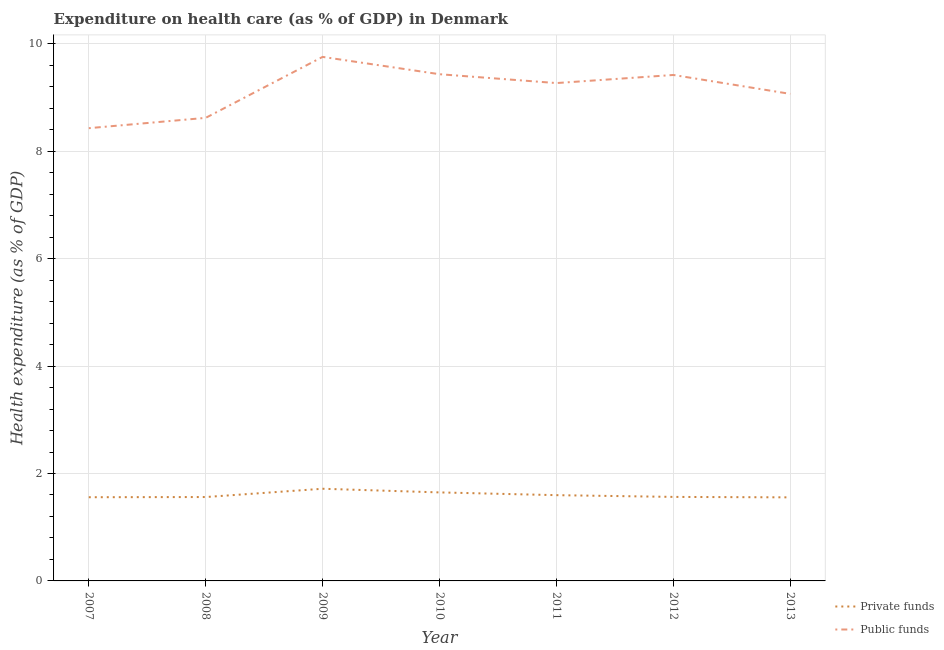How many different coloured lines are there?
Keep it short and to the point. 2. Does the line corresponding to amount of public funds spent in healthcare intersect with the line corresponding to amount of private funds spent in healthcare?
Your response must be concise. No. Is the number of lines equal to the number of legend labels?
Your answer should be very brief. Yes. What is the amount of public funds spent in healthcare in 2013?
Provide a short and direct response. 9.07. Across all years, what is the maximum amount of public funds spent in healthcare?
Provide a succinct answer. 9.76. Across all years, what is the minimum amount of public funds spent in healthcare?
Your answer should be very brief. 8.43. In which year was the amount of private funds spent in healthcare maximum?
Offer a terse response. 2009. What is the total amount of public funds spent in healthcare in the graph?
Your response must be concise. 64. What is the difference between the amount of public funds spent in healthcare in 2007 and that in 2012?
Your response must be concise. -0.99. What is the difference between the amount of public funds spent in healthcare in 2013 and the amount of private funds spent in healthcare in 2012?
Your answer should be very brief. 7.5. What is the average amount of private funds spent in healthcare per year?
Keep it short and to the point. 1.6. In the year 2013, what is the difference between the amount of public funds spent in healthcare and amount of private funds spent in healthcare?
Your answer should be very brief. 7.51. What is the ratio of the amount of private funds spent in healthcare in 2008 to that in 2013?
Offer a terse response. 1. Is the difference between the amount of private funds spent in healthcare in 2012 and 2013 greater than the difference between the amount of public funds spent in healthcare in 2012 and 2013?
Keep it short and to the point. No. What is the difference between the highest and the second highest amount of private funds spent in healthcare?
Keep it short and to the point. 0.07. What is the difference between the highest and the lowest amount of private funds spent in healthcare?
Provide a short and direct response. 0.16. Is the sum of the amount of public funds spent in healthcare in 2009 and 2010 greater than the maximum amount of private funds spent in healthcare across all years?
Your answer should be compact. Yes. Is the amount of public funds spent in healthcare strictly greater than the amount of private funds spent in healthcare over the years?
Give a very brief answer. Yes. Is the amount of public funds spent in healthcare strictly less than the amount of private funds spent in healthcare over the years?
Provide a short and direct response. No. How many lines are there?
Offer a very short reply. 2. How many years are there in the graph?
Offer a very short reply. 7. What is the difference between two consecutive major ticks on the Y-axis?
Provide a short and direct response. 2. Are the values on the major ticks of Y-axis written in scientific E-notation?
Your answer should be very brief. No. Does the graph contain grids?
Offer a terse response. Yes. How many legend labels are there?
Give a very brief answer. 2. What is the title of the graph?
Provide a short and direct response. Expenditure on health care (as % of GDP) in Denmark. What is the label or title of the X-axis?
Provide a short and direct response. Year. What is the label or title of the Y-axis?
Provide a succinct answer. Health expenditure (as % of GDP). What is the Health expenditure (as % of GDP) in Private funds in 2007?
Make the answer very short. 1.56. What is the Health expenditure (as % of GDP) in Public funds in 2007?
Offer a very short reply. 8.43. What is the Health expenditure (as % of GDP) in Private funds in 2008?
Give a very brief answer. 1.56. What is the Health expenditure (as % of GDP) in Public funds in 2008?
Your response must be concise. 8.62. What is the Health expenditure (as % of GDP) in Private funds in 2009?
Provide a succinct answer. 1.72. What is the Health expenditure (as % of GDP) of Public funds in 2009?
Give a very brief answer. 9.76. What is the Health expenditure (as % of GDP) of Private funds in 2010?
Offer a terse response. 1.65. What is the Health expenditure (as % of GDP) of Public funds in 2010?
Provide a short and direct response. 9.43. What is the Health expenditure (as % of GDP) of Private funds in 2011?
Provide a short and direct response. 1.6. What is the Health expenditure (as % of GDP) of Public funds in 2011?
Ensure brevity in your answer.  9.27. What is the Health expenditure (as % of GDP) in Private funds in 2012?
Your answer should be compact. 1.56. What is the Health expenditure (as % of GDP) of Public funds in 2012?
Your response must be concise. 9.42. What is the Health expenditure (as % of GDP) in Private funds in 2013?
Your response must be concise. 1.56. What is the Health expenditure (as % of GDP) in Public funds in 2013?
Provide a succinct answer. 9.07. Across all years, what is the maximum Health expenditure (as % of GDP) in Private funds?
Make the answer very short. 1.72. Across all years, what is the maximum Health expenditure (as % of GDP) of Public funds?
Make the answer very short. 9.76. Across all years, what is the minimum Health expenditure (as % of GDP) in Private funds?
Your answer should be very brief. 1.56. Across all years, what is the minimum Health expenditure (as % of GDP) of Public funds?
Make the answer very short. 8.43. What is the total Health expenditure (as % of GDP) of Private funds in the graph?
Keep it short and to the point. 11.2. What is the total Health expenditure (as % of GDP) in Public funds in the graph?
Ensure brevity in your answer.  64. What is the difference between the Health expenditure (as % of GDP) in Private funds in 2007 and that in 2008?
Offer a terse response. -0. What is the difference between the Health expenditure (as % of GDP) in Public funds in 2007 and that in 2008?
Offer a terse response. -0.19. What is the difference between the Health expenditure (as % of GDP) in Private funds in 2007 and that in 2009?
Give a very brief answer. -0.16. What is the difference between the Health expenditure (as % of GDP) in Public funds in 2007 and that in 2009?
Your response must be concise. -1.33. What is the difference between the Health expenditure (as % of GDP) of Private funds in 2007 and that in 2010?
Provide a short and direct response. -0.09. What is the difference between the Health expenditure (as % of GDP) of Public funds in 2007 and that in 2010?
Provide a short and direct response. -1. What is the difference between the Health expenditure (as % of GDP) in Private funds in 2007 and that in 2011?
Provide a short and direct response. -0.04. What is the difference between the Health expenditure (as % of GDP) in Public funds in 2007 and that in 2011?
Make the answer very short. -0.84. What is the difference between the Health expenditure (as % of GDP) in Private funds in 2007 and that in 2012?
Provide a short and direct response. -0.01. What is the difference between the Health expenditure (as % of GDP) of Public funds in 2007 and that in 2012?
Your response must be concise. -0.99. What is the difference between the Health expenditure (as % of GDP) of Private funds in 2007 and that in 2013?
Your answer should be very brief. 0. What is the difference between the Health expenditure (as % of GDP) in Public funds in 2007 and that in 2013?
Your response must be concise. -0.64. What is the difference between the Health expenditure (as % of GDP) of Private funds in 2008 and that in 2009?
Ensure brevity in your answer.  -0.15. What is the difference between the Health expenditure (as % of GDP) of Public funds in 2008 and that in 2009?
Provide a succinct answer. -1.13. What is the difference between the Health expenditure (as % of GDP) in Private funds in 2008 and that in 2010?
Your answer should be compact. -0.09. What is the difference between the Health expenditure (as % of GDP) in Public funds in 2008 and that in 2010?
Your response must be concise. -0.81. What is the difference between the Health expenditure (as % of GDP) of Private funds in 2008 and that in 2011?
Your response must be concise. -0.03. What is the difference between the Health expenditure (as % of GDP) in Public funds in 2008 and that in 2011?
Your answer should be compact. -0.65. What is the difference between the Health expenditure (as % of GDP) of Private funds in 2008 and that in 2012?
Offer a terse response. -0. What is the difference between the Health expenditure (as % of GDP) of Public funds in 2008 and that in 2012?
Offer a terse response. -0.8. What is the difference between the Health expenditure (as % of GDP) of Private funds in 2008 and that in 2013?
Keep it short and to the point. 0.01. What is the difference between the Health expenditure (as % of GDP) in Public funds in 2008 and that in 2013?
Your answer should be very brief. -0.45. What is the difference between the Health expenditure (as % of GDP) of Private funds in 2009 and that in 2010?
Provide a succinct answer. 0.07. What is the difference between the Health expenditure (as % of GDP) in Public funds in 2009 and that in 2010?
Your response must be concise. 0.32. What is the difference between the Health expenditure (as % of GDP) of Private funds in 2009 and that in 2011?
Offer a terse response. 0.12. What is the difference between the Health expenditure (as % of GDP) of Public funds in 2009 and that in 2011?
Offer a terse response. 0.49. What is the difference between the Health expenditure (as % of GDP) in Private funds in 2009 and that in 2012?
Make the answer very short. 0.15. What is the difference between the Health expenditure (as % of GDP) of Public funds in 2009 and that in 2012?
Your response must be concise. 0.34. What is the difference between the Health expenditure (as % of GDP) of Private funds in 2009 and that in 2013?
Your response must be concise. 0.16. What is the difference between the Health expenditure (as % of GDP) in Public funds in 2009 and that in 2013?
Make the answer very short. 0.69. What is the difference between the Health expenditure (as % of GDP) of Private funds in 2010 and that in 2011?
Provide a short and direct response. 0.05. What is the difference between the Health expenditure (as % of GDP) of Public funds in 2010 and that in 2011?
Your answer should be very brief. 0.17. What is the difference between the Health expenditure (as % of GDP) of Private funds in 2010 and that in 2012?
Your answer should be very brief. 0.08. What is the difference between the Health expenditure (as % of GDP) of Public funds in 2010 and that in 2012?
Offer a terse response. 0.01. What is the difference between the Health expenditure (as % of GDP) of Private funds in 2010 and that in 2013?
Make the answer very short. 0.09. What is the difference between the Health expenditure (as % of GDP) of Public funds in 2010 and that in 2013?
Your response must be concise. 0.37. What is the difference between the Health expenditure (as % of GDP) of Private funds in 2011 and that in 2012?
Make the answer very short. 0.03. What is the difference between the Health expenditure (as % of GDP) of Public funds in 2011 and that in 2012?
Provide a short and direct response. -0.15. What is the difference between the Health expenditure (as % of GDP) of Private funds in 2011 and that in 2013?
Offer a very short reply. 0.04. What is the difference between the Health expenditure (as % of GDP) in Public funds in 2011 and that in 2013?
Give a very brief answer. 0.2. What is the difference between the Health expenditure (as % of GDP) of Private funds in 2012 and that in 2013?
Your response must be concise. 0.01. What is the difference between the Health expenditure (as % of GDP) in Public funds in 2012 and that in 2013?
Your answer should be compact. 0.35. What is the difference between the Health expenditure (as % of GDP) of Private funds in 2007 and the Health expenditure (as % of GDP) of Public funds in 2008?
Your answer should be compact. -7.06. What is the difference between the Health expenditure (as % of GDP) in Private funds in 2007 and the Health expenditure (as % of GDP) in Public funds in 2009?
Your answer should be compact. -8.2. What is the difference between the Health expenditure (as % of GDP) of Private funds in 2007 and the Health expenditure (as % of GDP) of Public funds in 2010?
Provide a short and direct response. -7.88. What is the difference between the Health expenditure (as % of GDP) in Private funds in 2007 and the Health expenditure (as % of GDP) in Public funds in 2011?
Your response must be concise. -7.71. What is the difference between the Health expenditure (as % of GDP) of Private funds in 2007 and the Health expenditure (as % of GDP) of Public funds in 2012?
Provide a succinct answer. -7.86. What is the difference between the Health expenditure (as % of GDP) in Private funds in 2007 and the Health expenditure (as % of GDP) in Public funds in 2013?
Your answer should be very brief. -7.51. What is the difference between the Health expenditure (as % of GDP) in Private funds in 2008 and the Health expenditure (as % of GDP) in Public funds in 2009?
Offer a very short reply. -8.19. What is the difference between the Health expenditure (as % of GDP) of Private funds in 2008 and the Health expenditure (as % of GDP) of Public funds in 2010?
Offer a terse response. -7.87. What is the difference between the Health expenditure (as % of GDP) of Private funds in 2008 and the Health expenditure (as % of GDP) of Public funds in 2011?
Provide a short and direct response. -7.71. What is the difference between the Health expenditure (as % of GDP) of Private funds in 2008 and the Health expenditure (as % of GDP) of Public funds in 2012?
Make the answer very short. -7.86. What is the difference between the Health expenditure (as % of GDP) in Private funds in 2008 and the Health expenditure (as % of GDP) in Public funds in 2013?
Your answer should be compact. -7.51. What is the difference between the Health expenditure (as % of GDP) in Private funds in 2009 and the Health expenditure (as % of GDP) in Public funds in 2010?
Your response must be concise. -7.72. What is the difference between the Health expenditure (as % of GDP) of Private funds in 2009 and the Health expenditure (as % of GDP) of Public funds in 2011?
Provide a short and direct response. -7.55. What is the difference between the Health expenditure (as % of GDP) of Private funds in 2009 and the Health expenditure (as % of GDP) of Public funds in 2012?
Make the answer very short. -7.7. What is the difference between the Health expenditure (as % of GDP) of Private funds in 2009 and the Health expenditure (as % of GDP) of Public funds in 2013?
Your answer should be very brief. -7.35. What is the difference between the Health expenditure (as % of GDP) in Private funds in 2010 and the Health expenditure (as % of GDP) in Public funds in 2011?
Give a very brief answer. -7.62. What is the difference between the Health expenditure (as % of GDP) in Private funds in 2010 and the Health expenditure (as % of GDP) in Public funds in 2012?
Give a very brief answer. -7.77. What is the difference between the Health expenditure (as % of GDP) of Private funds in 2010 and the Health expenditure (as % of GDP) of Public funds in 2013?
Your answer should be very brief. -7.42. What is the difference between the Health expenditure (as % of GDP) in Private funds in 2011 and the Health expenditure (as % of GDP) in Public funds in 2012?
Provide a short and direct response. -7.82. What is the difference between the Health expenditure (as % of GDP) of Private funds in 2011 and the Health expenditure (as % of GDP) of Public funds in 2013?
Your response must be concise. -7.47. What is the difference between the Health expenditure (as % of GDP) of Private funds in 2012 and the Health expenditure (as % of GDP) of Public funds in 2013?
Make the answer very short. -7.5. What is the average Health expenditure (as % of GDP) of Private funds per year?
Make the answer very short. 1.6. What is the average Health expenditure (as % of GDP) of Public funds per year?
Provide a short and direct response. 9.14. In the year 2007, what is the difference between the Health expenditure (as % of GDP) in Private funds and Health expenditure (as % of GDP) in Public funds?
Offer a terse response. -6.87. In the year 2008, what is the difference between the Health expenditure (as % of GDP) of Private funds and Health expenditure (as % of GDP) of Public funds?
Your response must be concise. -7.06. In the year 2009, what is the difference between the Health expenditure (as % of GDP) of Private funds and Health expenditure (as % of GDP) of Public funds?
Offer a very short reply. -8.04. In the year 2010, what is the difference between the Health expenditure (as % of GDP) of Private funds and Health expenditure (as % of GDP) of Public funds?
Your response must be concise. -7.79. In the year 2011, what is the difference between the Health expenditure (as % of GDP) of Private funds and Health expenditure (as % of GDP) of Public funds?
Your answer should be compact. -7.67. In the year 2012, what is the difference between the Health expenditure (as % of GDP) of Private funds and Health expenditure (as % of GDP) of Public funds?
Provide a succinct answer. -7.86. In the year 2013, what is the difference between the Health expenditure (as % of GDP) of Private funds and Health expenditure (as % of GDP) of Public funds?
Offer a terse response. -7.51. What is the ratio of the Health expenditure (as % of GDP) of Public funds in 2007 to that in 2008?
Provide a short and direct response. 0.98. What is the ratio of the Health expenditure (as % of GDP) of Private funds in 2007 to that in 2009?
Your answer should be very brief. 0.91. What is the ratio of the Health expenditure (as % of GDP) of Public funds in 2007 to that in 2009?
Ensure brevity in your answer.  0.86. What is the ratio of the Health expenditure (as % of GDP) of Private funds in 2007 to that in 2010?
Keep it short and to the point. 0.95. What is the ratio of the Health expenditure (as % of GDP) of Public funds in 2007 to that in 2010?
Give a very brief answer. 0.89. What is the ratio of the Health expenditure (as % of GDP) of Private funds in 2007 to that in 2011?
Provide a succinct answer. 0.98. What is the ratio of the Health expenditure (as % of GDP) in Public funds in 2007 to that in 2011?
Make the answer very short. 0.91. What is the ratio of the Health expenditure (as % of GDP) in Public funds in 2007 to that in 2012?
Your answer should be very brief. 0.89. What is the ratio of the Health expenditure (as % of GDP) in Public funds in 2007 to that in 2013?
Your answer should be compact. 0.93. What is the ratio of the Health expenditure (as % of GDP) in Private funds in 2008 to that in 2009?
Provide a succinct answer. 0.91. What is the ratio of the Health expenditure (as % of GDP) in Public funds in 2008 to that in 2009?
Offer a very short reply. 0.88. What is the ratio of the Health expenditure (as % of GDP) in Private funds in 2008 to that in 2010?
Ensure brevity in your answer.  0.95. What is the ratio of the Health expenditure (as % of GDP) in Public funds in 2008 to that in 2010?
Your response must be concise. 0.91. What is the ratio of the Health expenditure (as % of GDP) of Private funds in 2008 to that in 2011?
Your answer should be very brief. 0.98. What is the ratio of the Health expenditure (as % of GDP) of Public funds in 2008 to that in 2011?
Offer a very short reply. 0.93. What is the ratio of the Health expenditure (as % of GDP) in Private funds in 2008 to that in 2012?
Make the answer very short. 1. What is the ratio of the Health expenditure (as % of GDP) in Public funds in 2008 to that in 2012?
Your answer should be very brief. 0.92. What is the ratio of the Health expenditure (as % of GDP) in Private funds in 2008 to that in 2013?
Your answer should be compact. 1. What is the ratio of the Health expenditure (as % of GDP) in Public funds in 2008 to that in 2013?
Offer a very short reply. 0.95. What is the ratio of the Health expenditure (as % of GDP) in Private funds in 2009 to that in 2010?
Give a very brief answer. 1.04. What is the ratio of the Health expenditure (as % of GDP) of Public funds in 2009 to that in 2010?
Your answer should be very brief. 1.03. What is the ratio of the Health expenditure (as % of GDP) in Private funds in 2009 to that in 2011?
Your response must be concise. 1.07. What is the ratio of the Health expenditure (as % of GDP) of Public funds in 2009 to that in 2011?
Offer a terse response. 1.05. What is the ratio of the Health expenditure (as % of GDP) in Private funds in 2009 to that in 2012?
Your response must be concise. 1.1. What is the ratio of the Health expenditure (as % of GDP) of Public funds in 2009 to that in 2012?
Provide a short and direct response. 1.04. What is the ratio of the Health expenditure (as % of GDP) in Private funds in 2009 to that in 2013?
Your response must be concise. 1.1. What is the ratio of the Health expenditure (as % of GDP) in Public funds in 2009 to that in 2013?
Your answer should be compact. 1.08. What is the ratio of the Health expenditure (as % of GDP) of Private funds in 2010 to that in 2011?
Keep it short and to the point. 1.03. What is the ratio of the Health expenditure (as % of GDP) in Public funds in 2010 to that in 2011?
Your answer should be very brief. 1.02. What is the ratio of the Health expenditure (as % of GDP) of Private funds in 2010 to that in 2012?
Keep it short and to the point. 1.05. What is the ratio of the Health expenditure (as % of GDP) of Public funds in 2010 to that in 2012?
Give a very brief answer. 1. What is the ratio of the Health expenditure (as % of GDP) in Private funds in 2010 to that in 2013?
Provide a succinct answer. 1.06. What is the ratio of the Health expenditure (as % of GDP) of Public funds in 2010 to that in 2013?
Give a very brief answer. 1.04. What is the ratio of the Health expenditure (as % of GDP) in Private funds in 2011 to that in 2012?
Your answer should be very brief. 1.02. What is the ratio of the Health expenditure (as % of GDP) in Private funds in 2011 to that in 2013?
Give a very brief answer. 1.03. What is the ratio of the Health expenditure (as % of GDP) of Public funds in 2011 to that in 2013?
Provide a short and direct response. 1.02. What is the ratio of the Health expenditure (as % of GDP) in Private funds in 2012 to that in 2013?
Offer a very short reply. 1.01. What is the ratio of the Health expenditure (as % of GDP) of Public funds in 2012 to that in 2013?
Offer a terse response. 1.04. What is the difference between the highest and the second highest Health expenditure (as % of GDP) of Private funds?
Ensure brevity in your answer.  0.07. What is the difference between the highest and the second highest Health expenditure (as % of GDP) in Public funds?
Make the answer very short. 0.32. What is the difference between the highest and the lowest Health expenditure (as % of GDP) in Private funds?
Your answer should be very brief. 0.16. What is the difference between the highest and the lowest Health expenditure (as % of GDP) in Public funds?
Provide a succinct answer. 1.33. 